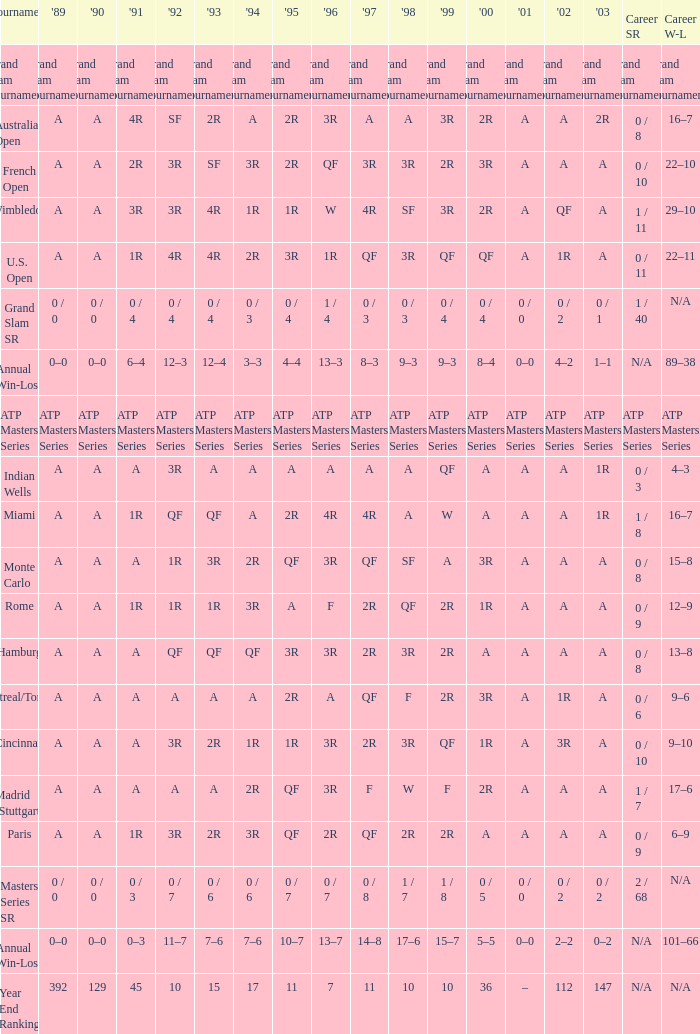What was the career SR with a value of A in 1980 and F in 1997? 1 / 7. 